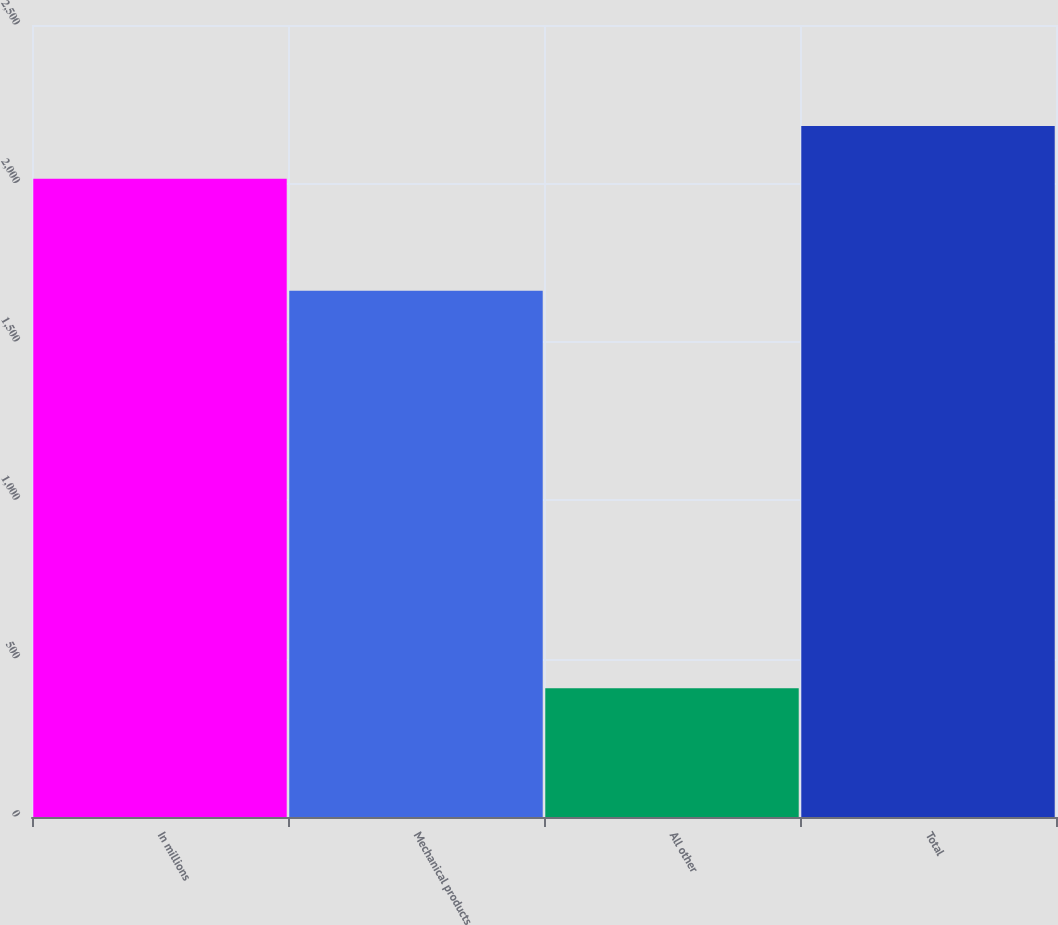Convert chart to OTSL. <chart><loc_0><loc_0><loc_500><loc_500><bar_chart><fcel>In millions<fcel>Mechanical products<fcel>All other<fcel>Total<nl><fcel>2015<fcel>1661.4<fcel>406.7<fcel>2181.14<nl></chart> 